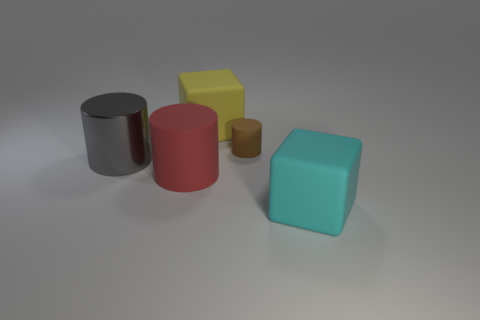Are there any other things that are the same size as the brown rubber object?
Make the answer very short. No. What shape is the big cyan object?
Ensure brevity in your answer.  Cube. There is a large matte thing that is to the left of the big yellow rubber cube; are there any cyan blocks behind it?
Offer a terse response. No. There is a rubber object that is in front of the big matte cylinder; how many large red matte objects are behind it?
Your answer should be compact. 1. There is a cube that is the same size as the yellow object; what is its material?
Your response must be concise. Rubber. There is a big thing that is right of the tiny cylinder; is its shape the same as the large yellow matte thing?
Keep it short and to the point. Yes. Is the number of large matte things that are behind the gray metallic cylinder greater than the number of gray objects in front of the red rubber cylinder?
Ensure brevity in your answer.  Yes. What number of cylinders are made of the same material as the cyan thing?
Make the answer very short. 2. Is the gray shiny cylinder the same size as the red object?
Ensure brevity in your answer.  Yes. The big metallic cylinder is what color?
Offer a terse response. Gray. 